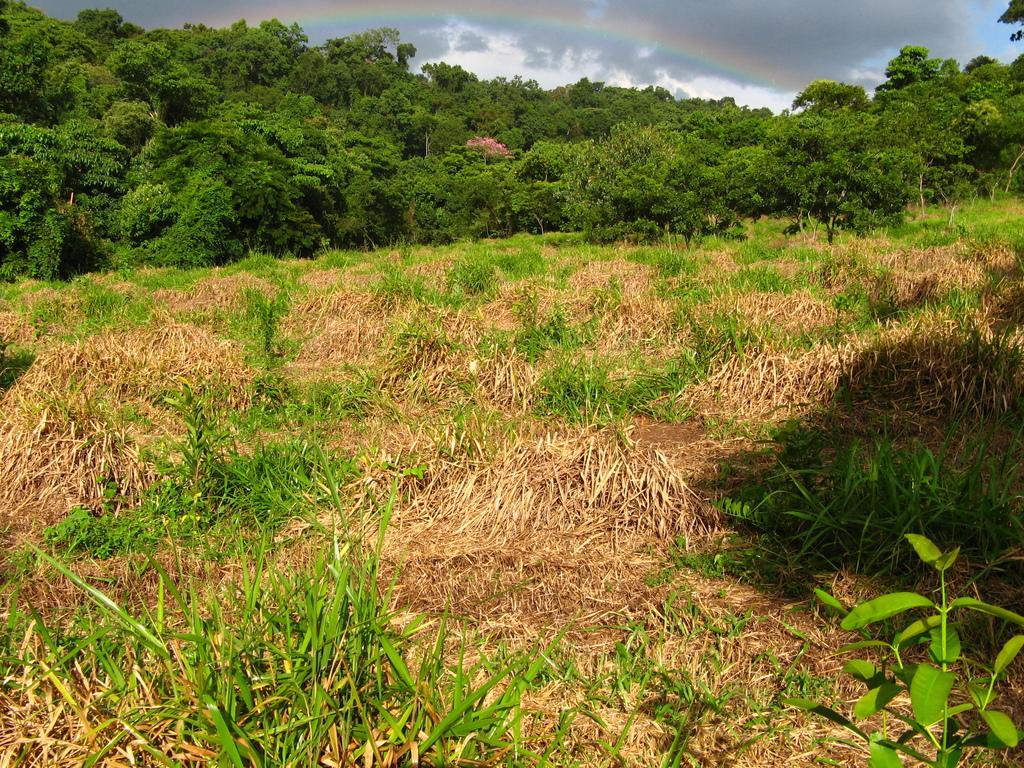How would you summarize this image in a sentence or two? At the bottom of the image there is grass. In the background of the image there are trees, sky and rainbow. 